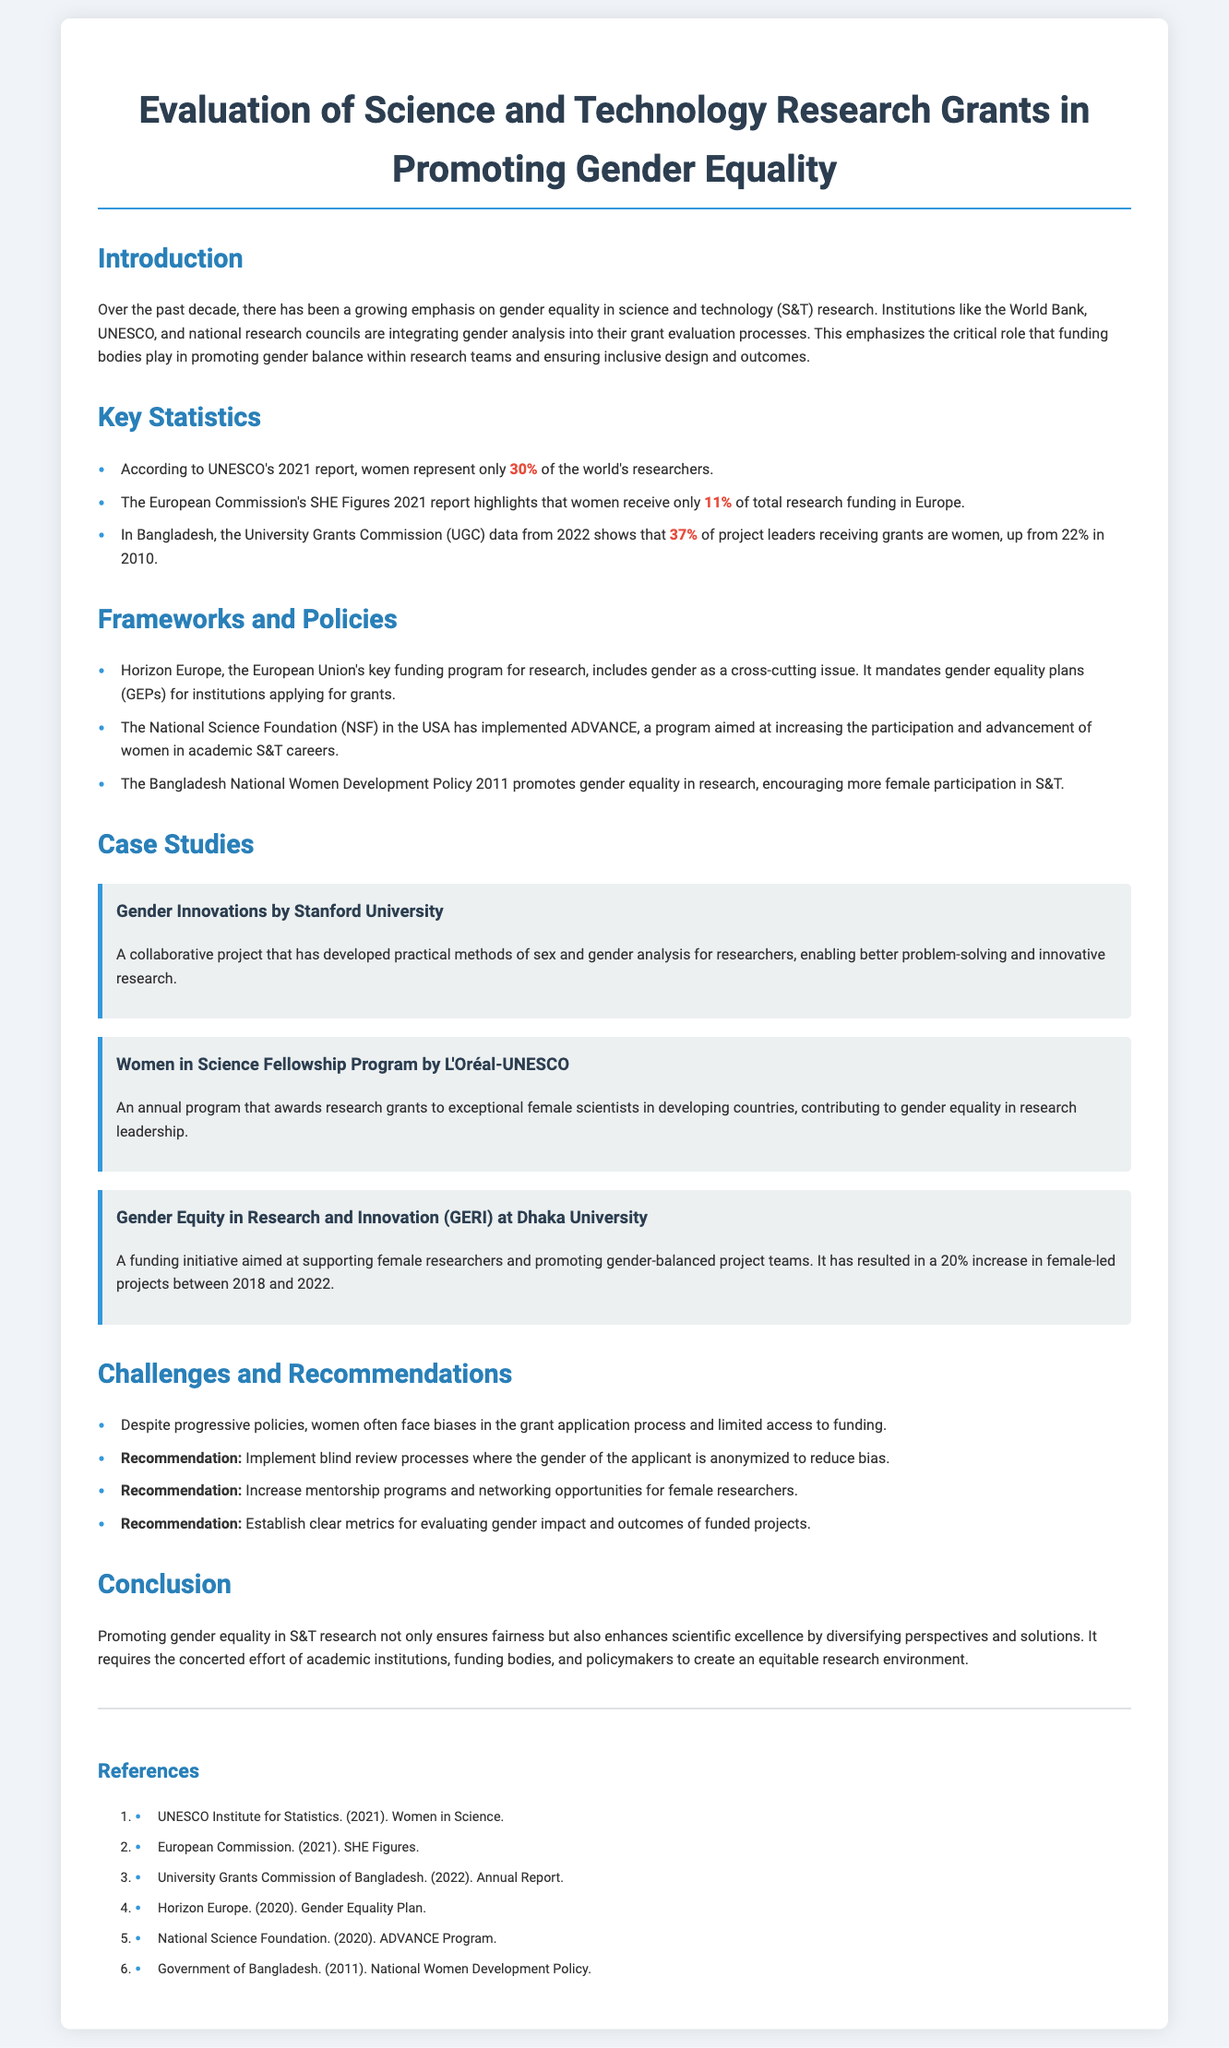what percentage of researchers are women according to UNESCO's report? The document states that according to UNESCO's 2021 report, women represent only 30% of the world's researchers.
Answer: 30% what is the percentage increase of female project leaders in Bangladesh from 2010 to 2022? The document indicates that in Bangladesh, the percentage of project leaders who are women increased from 22% in 2010 to 37% in 2022, which is a 15% increase.
Answer: 15% what program does the National Science Foundation (NSF) implement to support women in academic S&T careers? The document mentions that the NSF has implemented the ADVANCE program aimed at increasing female participation and advancement.
Answer: ADVANCE which funding initiative supports female researchers at Dhaka University? The document notes that the Gender Equity in Research and Innovation (GERI) is a funding initiative aimed at supporting female researchers.
Answer: GERI what is a recommended strategy to reduce bias in the grant application process? The document recommends implementing blind review processes where the gender of the applicant is anonymized to reduce bias.
Answer: blind review processes what organization produced the SHE Figures report? The document states that the European Commission produced the SHE Figures 2021 report.
Answer: European Commission how much of total research funding in Europe do women receive? The document indicates that women receive only 11% of total research funding in Europe.
Answer: 11% what was the percentage of female-led projects increase between 2018 and 2022 due to GERI? The document cites a 20% increase in female-led projects due to the GERI initiative.
Answer: 20% what policy promotes gender equality in research in Bangladesh? The document identifies the Bangladesh National Women Development Policy 2011 as promoting gender equality in research.
Answer: Bangladesh National Women Development Policy 2011 